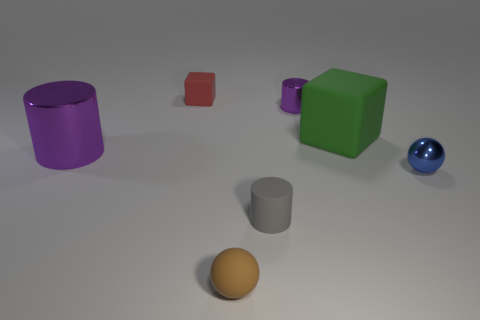There is a block that is right of the purple cylinder that is behind the purple shiny thing that is in front of the tiny purple cylinder; what is its material?
Your answer should be compact. Rubber. Is the number of purple metallic cylinders behind the small matte ball less than the number of tiny metallic cylinders?
Offer a terse response. No. There is another cylinder that is the same size as the matte cylinder; what material is it?
Your answer should be compact. Metal. There is a cylinder that is both right of the red rubber object and in front of the big green rubber thing; what size is it?
Your answer should be very brief. Small. What is the size of the other purple thing that is the same shape as the tiny purple thing?
Ensure brevity in your answer.  Large. What number of objects are tiny red things or things in front of the large shiny thing?
Provide a short and direct response. 4. What is the shape of the small brown matte object?
Give a very brief answer. Sphere. What shape is the thing that is behind the purple shiny object on the right side of the small brown rubber ball?
Make the answer very short. Cube. What is the color of the sphere that is the same material as the large green block?
Your answer should be very brief. Brown. Is the color of the small cylinder that is behind the gray cylinder the same as the cylinder to the left of the tiny red block?
Keep it short and to the point. Yes. 